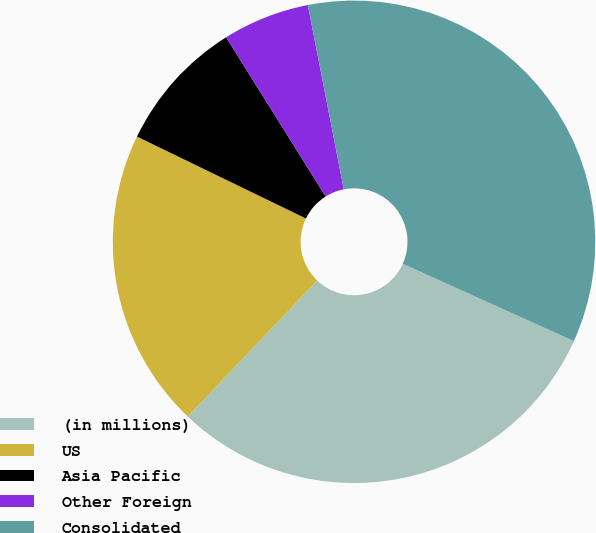Convert chart. <chart><loc_0><loc_0><loc_500><loc_500><pie_chart><fcel>(in millions)<fcel>US<fcel>Asia Pacific<fcel>Other Foreign<fcel>Consolidated<nl><fcel>30.35%<fcel>20.08%<fcel>8.92%<fcel>5.83%<fcel>34.82%<nl></chart> 